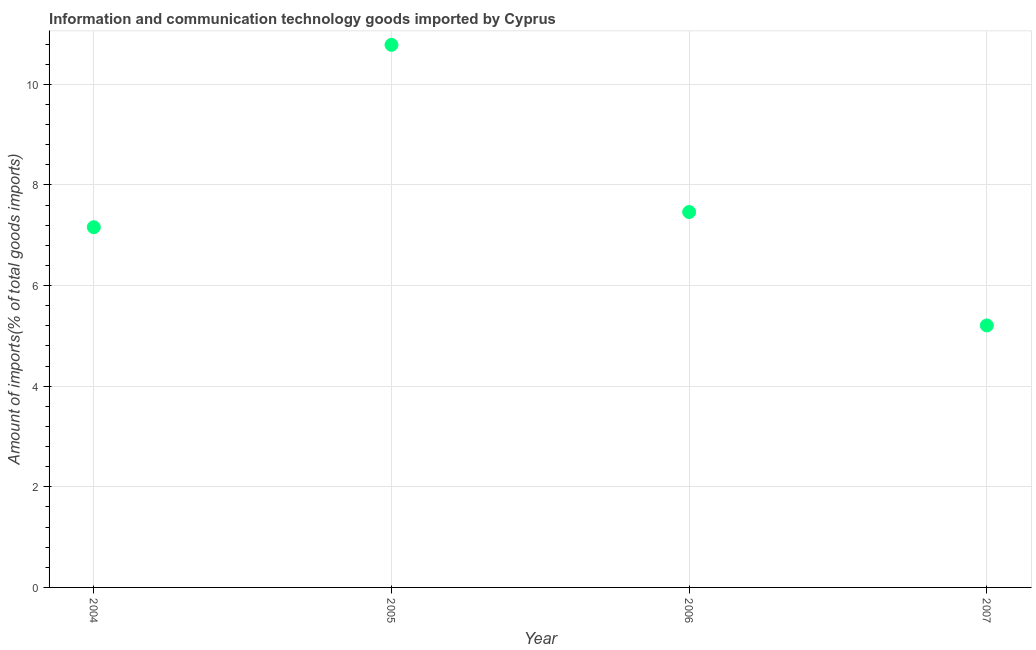What is the amount of ict goods imports in 2006?
Give a very brief answer. 7.46. Across all years, what is the maximum amount of ict goods imports?
Your response must be concise. 10.78. Across all years, what is the minimum amount of ict goods imports?
Provide a succinct answer. 5.21. In which year was the amount of ict goods imports minimum?
Give a very brief answer. 2007. What is the sum of the amount of ict goods imports?
Provide a short and direct response. 30.61. What is the difference between the amount of ict goods imports in 2004 and 2005?
Provide a succinct answer. -3.62. What is the average amount of ict goods imports per year?
Ensure brevity in your answer.  7.65. What is the median amount of ict goods imports?
Ensure brevity in your answer.  7.31. Do a majority of the years between 2007 and 2004 (inclusive) have amount of ict goods imports greater than 10 %?
Ensure brevity in your answer.  Yes. What is the ratio of the amount of ict goods imports in 2004 to that in 2006?
Make the answer very short. 0.96. Is the difference between the amount of ict goods imports in 2004 and 2007 greater than the difference between any two years?
Your response must be concise. No. What is the difference between the highest and the second highest amount of ict goods imports?
Make the answer very short. 3.32. Is the sum of the amount of ict goods imports in 2005 and 2006 greater than the maximum amount of ict goods imports across all years?
Your answer should be very brief. Yes. What is the difference between the highest and the lowest amount of ict goods imports?
Offer a very short reply. 5.58. Does the amount of ict goods imports monotonically increase over the years?
Give a very brief answer. No. What is the title of the graph?
Provide a succinct answer. Information and communication technology goods imported by Cyprus. What is the label or title of the Y-axis?
Provide a short and direct response. Amount of imports(% of total goods imports). What is the Amount of imports(% of total goods imports) in 2004?
Provide a succinct answer. 7.16. What is the Amount of imports(% of total goods imports) in 2005?
Ensure brevity in your answer.  10.78. What is the Amount of imports(% of total goods imports) in 2006?
Your response must be concise. 7.46. What is the Amount of imports(% of total goods imports) in 2007?
Provide a succinct answer. 5.21. What is the difference between the Amount of imports(% of total goods imports) in 2004 and 2005?
Make the answer very short. -3.62. What is the difference between the Amount of imports(% of total goods imports) in 2004 and 2006?
Offer a very short reply. -0.3. What is the difference between the Amount of imports(% of total goods imports) in 2004 and 2007?
Make the answer very short. 1.95. What is the difference between the Amount of imports(% of total goods imports) in 2005 and 2006?
Make the answer very short. 3.32. What is the difference between the Amount of imports(% of total goods imports) in 2005 and 2007?
Keep it short and to the point. 5.58. What is the difference between the Amount of imports(% of total goods imports) in 2006 and 2007?
Keep it short and to the point. 2.25. What is the ratio of the Amount of imports(% of total goods imports) in 2004 to that in 2005?
Your answer should be compact. 0.66. What is the ratio of the Amount of imports(% of total goods imports) in 2004 to that in 2006?
Keep it short and to the point. 0.96. What is the ratio of the Amount of imports(% of total goods imports) in 2004 to that in 2007?
Offer a terse response. 1.38. What is the ratio of the Amount of imports(% of total goods imports) in 2005 to that in 2006?
Your answer should be very brief. 1.45. What is the ratio of the Amount of imports(% of total goods imports) in 2005 to that in 2007?
Provide a short and direct response. 2.07. What is the ratio of the Amount of imports(% of total goods imports) in 2006 to that in 2007?
Keep it short and to the point. 1.43. 